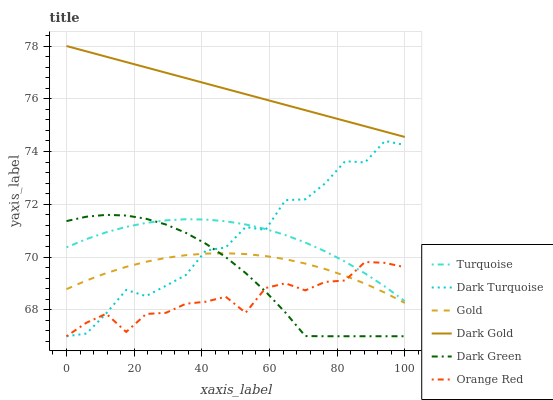Does Orange Red have the minimum area under the curve?
Answer yes or no. Yes. Does Dark Gold have the maximum area under the curve?
Answer yes or no. Yes. Does Gold have the minimum area under the curve?
Answer yes or no. No. Does Gold have the maximum area under the curve?
Answer yes or no. No. Is Dark Gold the smoothest?
Answer yes or no. Yes. Is Dark Turquoise the roughest?
Answer yes or no. Yes. Is Gold the smoothest?
Answer yes or no. No. Is Gold the roughest?
Answer yes or no. No. Does Dark Turquoise have the lowest value?
Answer yes or no. Yes. Does Gold have the lowest value?
Answer yes or no. No. Does Dark Gold have the highest value?
Answer yes or no. Yes. Does Gold have the highest value?
Answer yes or no. No. Is Orange Red less than Dark Gold?
Answer yes or no. Yes. Is Dark Gold greater than Dark Green?
Answer yes or no. Yes. Does Dark Green intersect Orange Red?
Answer yes or no. Yes. Is Dark Green less than Orange Red?
Answer yes or no. No. Is Dark Green greater than Orange Red?
Answer yes or no. No. Does Orange Red intersect Dark Gold?
Answer yes or no. No. 